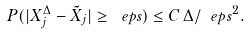Convert formula to latex. <formula><loc_0><loc_0><loc_500><loc_500>P ( | X _ { j } ^ { \Delta } - \tilde { X } _ { j } | \geq \ e p s ) \leq C \, { \Delta / \ e p s ^ { 2 } } .</formula> 